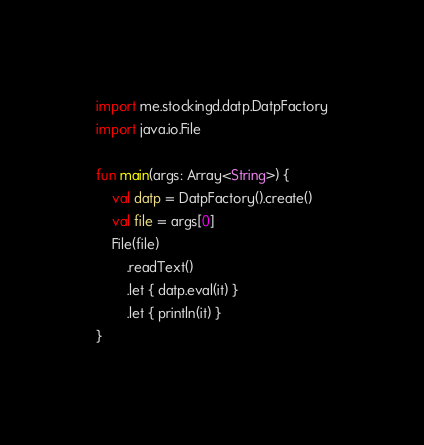Convert code to text. <code><loc_0><loc_0><loc_500><loc_500><_Kotlin_>import me.stockingd.datp.DatpFactory
import java.io.File

fun main(args: Array<String>) {
    val datp = DatpFactory().create()
    val file = args[0]
    File(file)
        .readText()
        .let { datp.eval(it) }
        .let { println(it) }
}</code> 